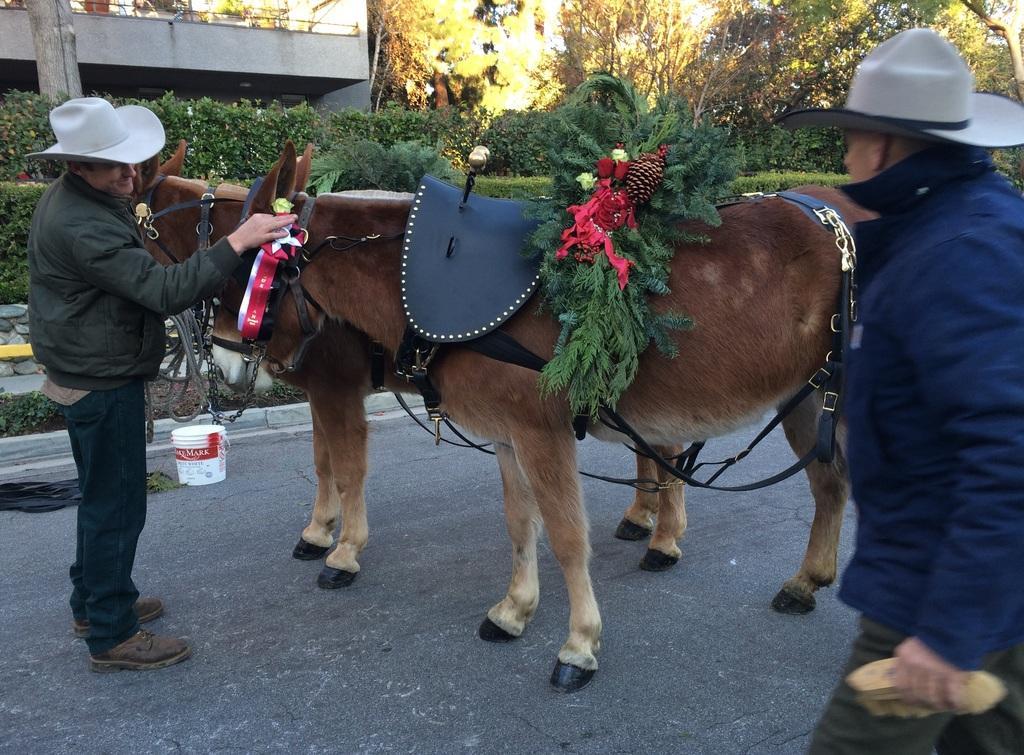Please provide a concise description of this image. In this image we can see two men wearing the hats standing on the road. We can also see two horses a bucket beside them. On the backside we can see some plants, a group of trees, a building and the sky. 